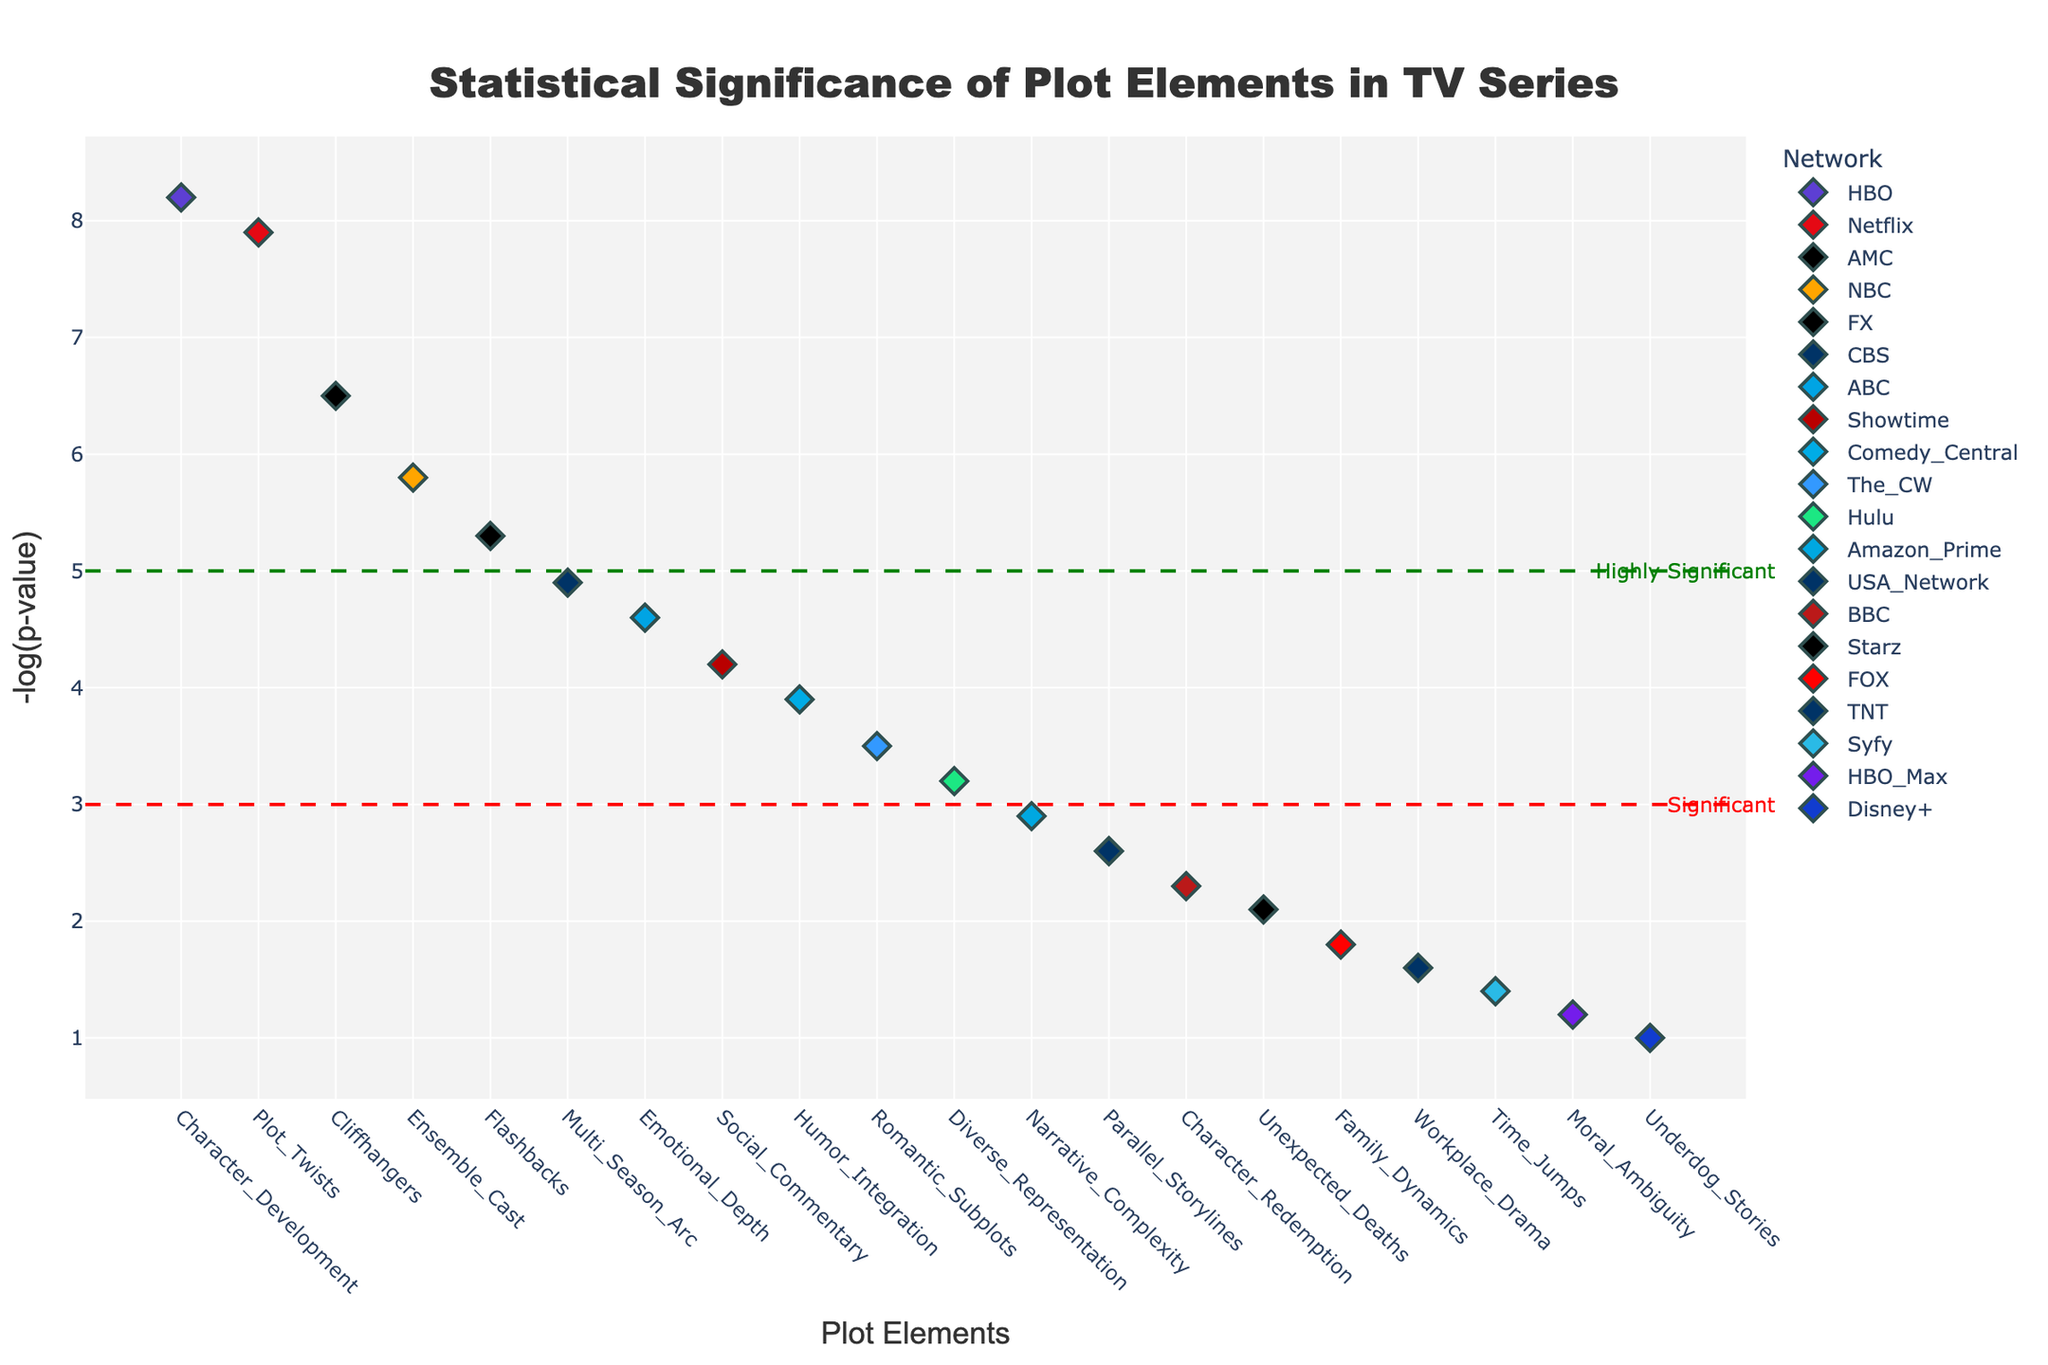What is the title of the plot? The title is always displayed prominently at the top of the figure. In this case, it is displayed in a larger font and centered.
Answer: Statistical Significance of Plot Elements in TV Series Which network has the most significant plot element? The most significant plot element has the highest -log(p-value), and looking at the height of the markers will indicate this. The highest marker is for "Character Development" which belongs to HBO.
Answer: HBO What is the y-axis title? The y-axis title is usually found along the vertical axis of the plot and it describes what each y-axis label represents.
Answer: -log(p-value) How many plot elements are on the "Highly Significant" line? The "Highly Significant" line is drawn at y=5. Counting the markers above this line will give the answer. There are 5 markers significantly above the line.
Answer: 5 Which plot element on NBC has the highest significance? To answer this, look at the markers for NBC (in orange color) and find the one that is the highest on the y-axis.
Answer: Ensemble Cast What is the significance value of "Flashbacks" on FX? To find this, locate the "Flashbacks" marker and read its y-axis value, which represents the -log(p-value).
Answer: 5.3 Which plot element has the lowest significance on Amazon Prime? Locate the markers for Amazon Prime (color: blue), then find the lowest among them. The lowest value on the y-axis represents the lowest significance.
Answer: Narrative Complexity Among "Plot Twists" on Netflix and "Unexpected Deaths" on Starz, which plot element is more significant? Compare the y-values (height) of the markers for "Plot Twists" on Netflix and "Unexpected Deaths" on Starz. The higher the marker, the more significant it is.
Answer: Plot Twists What is the difference in significance between "Character Development" on HBO and "Humor Integration" on Comedy Central? Find the y-values of both markers and subtract the y-value of "Humor Integration" from the y-value of "Character Development". The significance of "Character Development" is 8.2 and "Humor Integration" is 3.9, so the difference is 8.2 - 3.9.
Answer: 4.3 